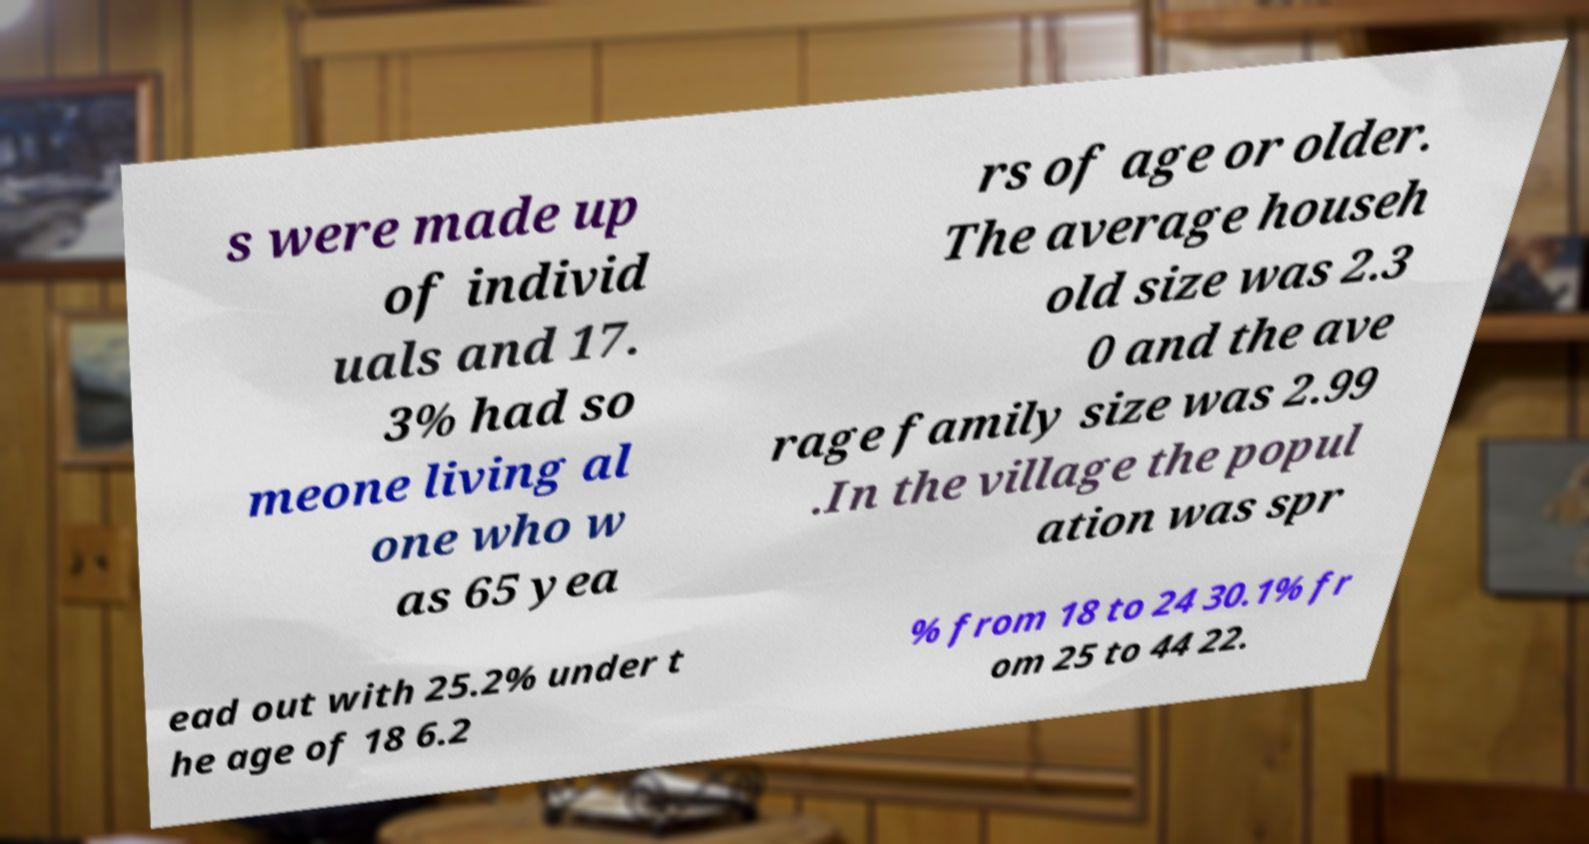Can you accurately transcribe the text from the provided image for me? s were made up of individ uals and 17. 3% had so meone living al one who w as 65 yea rs of age or older. The average househ old size was 2.3 0 and the ave rage family size was 2.99 .In the village the popul ation was spr ead out with 25.2% under t he age of 18 6.2 % from 18 to 24 30.1% fr om 25 to 44 22. 